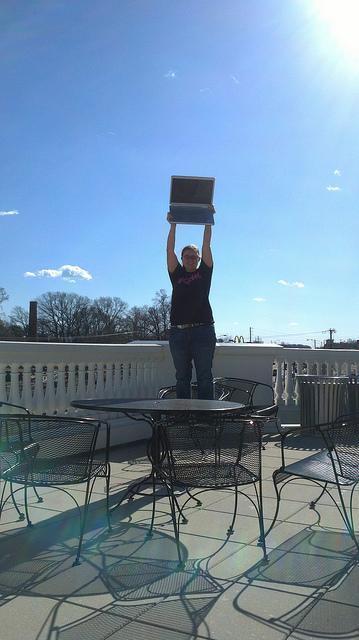How many chairs are visible?
Give a very brief answer. 4. 